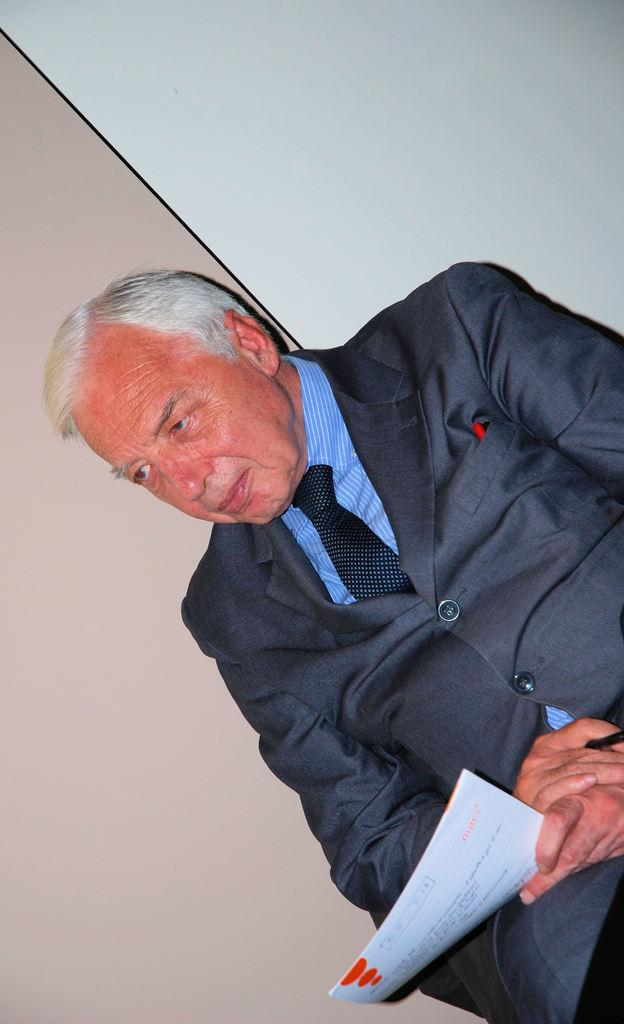What is the main subject of the image? There is a person in the image. What is the person wearing? The person is wearing an ash coat and tie. What is the person holding in the image? The person is holding papers. Can you describe the background of the image? There is a cream and white wall in the background of the image. What type of bells can be heard ringing in the image? There are no bells present in the image, and therefore no sound can be heard. Is there a donkey visible in the image? No, there is no donkey present in the image. 